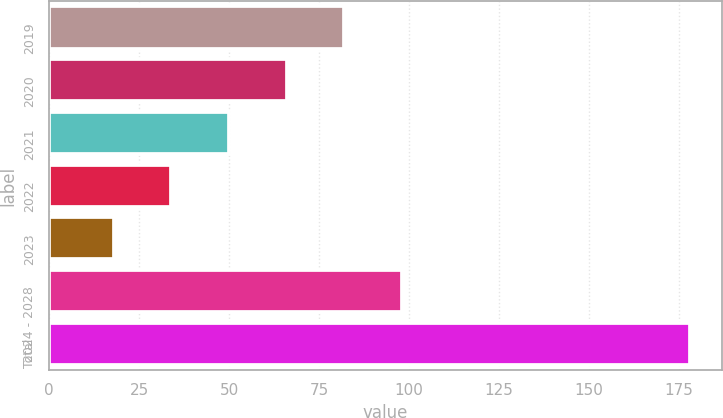Convert chart. <chart><loc_0><loc_0><loc_500><loc_500><bar_chart><fcel>2019<fcel>2020<fcel>2021<fcel>2022<fcel>2023<fcel>2024 - 2028<fcel>Total<nl><fcel>82<fcel>66<fcel>50<fcel>34<fcel>18<fcel>98<fcel>178<nl></chart> 